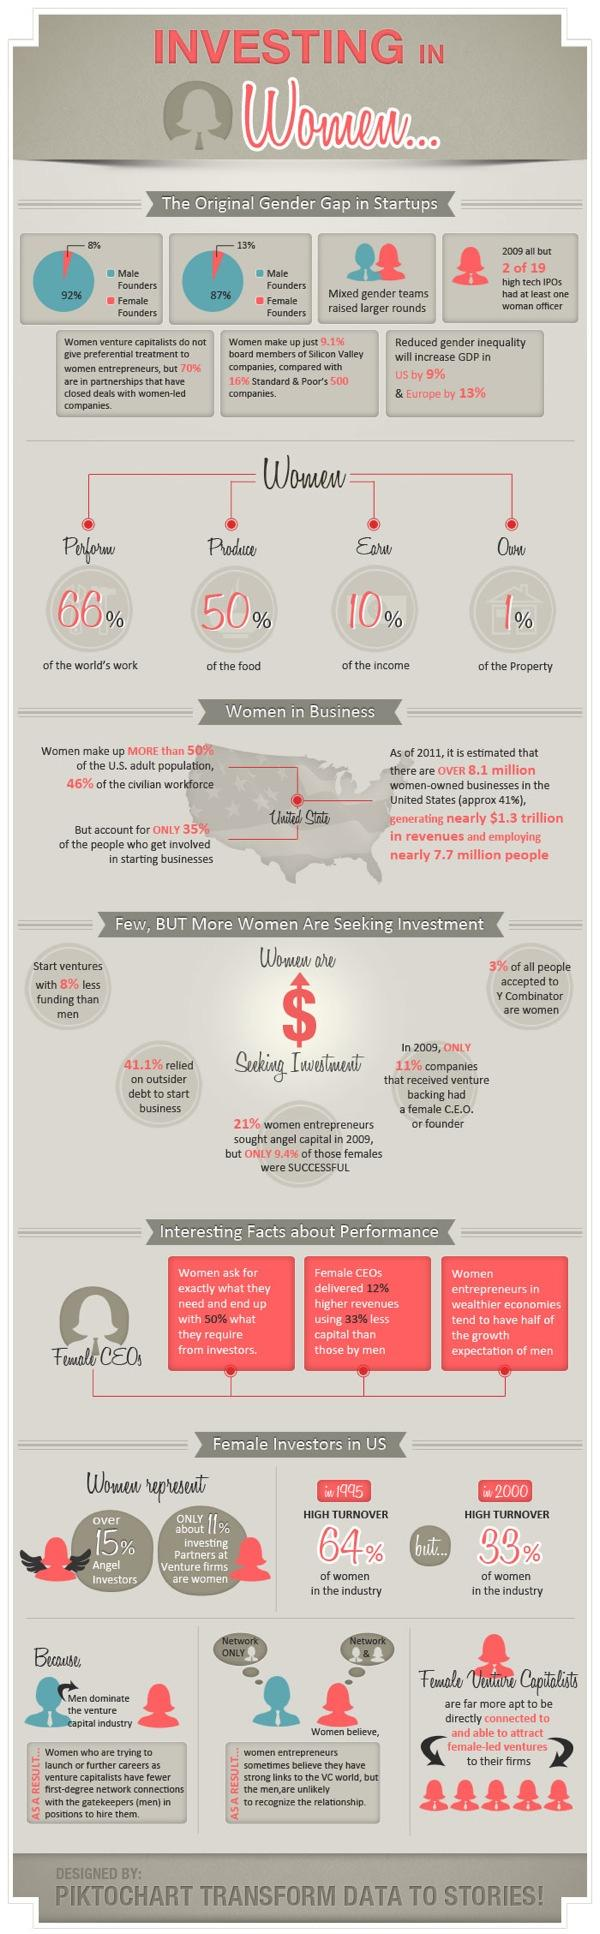Mention a couple of crucial points in this snapshot. In 2009, out of the women who sought angel capital, 90.6% were successful in their ventures. According to recent data, more than 15% of angel investors are women. It is estimated that women contribute approximately 50% of the food production globally. In 2000, the turnover of women reduced by a certain percentage when compared to 1995. In 2009, approximately 89% of companies that received venture backing did not have a female CEO or founder. 